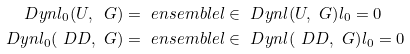<formula> <loc_0><loc_0><loc_500><loc_500>\ D y n l _ { 0 } ( U , \ G ) & = \ e n s e m b l e { l \in \ D y n l ( U , \ G ) } { l _ { 0 } = 0 } \\ \ D y n l _ { 0 } ( \ D D , \ G ) & = \ e n s e m b l e { l \in \ D y n l ( \ D D , \ G ) } { l _ { 0 } = 0 }</formula> 